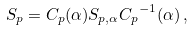Convert formula to latex. <formula><loc_0><loc_0><loc_500><loc_500>S _ { p } = C _ { p } ( \alpha ) S _ { p , \alpha } { C _ { p } } ^ { - 1 } ( \alpha ) \, ,</formula> 